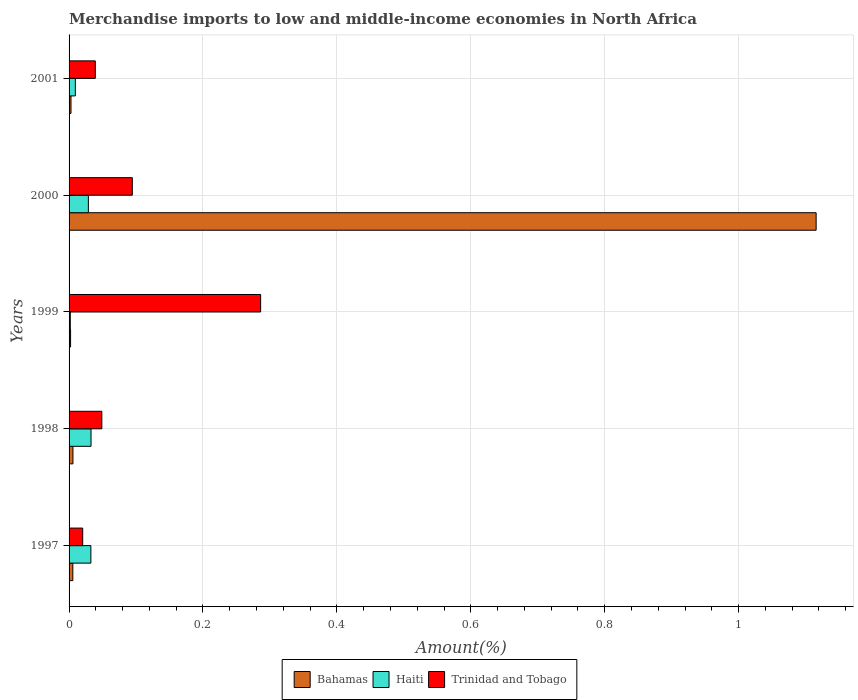How many different coloured bars are there?
Your answer should be compact. 3. Are the number of bars on each tick of the Y-axis equal?
Offer a very short reply. Yes. How many bars are there on the 2nd tick from the top?
Keep it short and to the point. 3. How many bars are there on the 1st tick from the bottom?
Offer a very short reply. 3. What is the percentage of amount earned from merchandise imports in Haiti in 2000?
Make the answer very short. 0.03. Across all years, what is the maximum percentage of amount earned from merchandise imports in Trinidad and Tobago?
Provide a short and direct response. 0.29. Across all years, what is the minimum percentage of amount earned from merchandise imports in Trinidad and Tobago?
Provide a succinct answer. 0.02. In which year was the percentage of amount earned from merchandise imports in Bahamas maximum?
Give a very brief answer. 2000. What is the total percentage of amount earned from merchandise imports in Trinidad and Tobago in the graph?
Make the answer very short. 0.49. What is the difference between the percentage of amount earned from merchandise imports in Bahamas in 1999 and that in 2001?
Give a very brief answer. -0. What is the difference between the percentage of amount earned from merchandise imports in Haiti in 2000 and the percentage of amount earned from merchandise imports in Trinidad and Tobago in 1997?
Make the answer very short. 0.01. What is the average percentage of amount earned from merchandise imports in Trinidad and Tobago per year?
Make the answer very short. 0.1. In the year 1998, what is the difference between the percentage of amount earned from merchandise imports in Bahamas and percentage of amount earned from merchandise imports in Trinidad and Tobago?
Your answer should be very brief. -0.04. In how many years, is the percentage of amount earned from merchandise imports in Haiti greater than 0.28 %?
Offer a terse response. 0. What is the ratio of the percentage of amount earned from merchandise imports in Bahamas in 1997 to that in 1999?
Offer a very short reply. 2.49. Is the difference between the percentage of amount earned from merchandise imports in Bahamas in 1997 and 2000 greater than the difference between the percentage of amount earned from merchandise imports in Trinidad and Tobago in 1997 and 2000?
Provide a succinct answer. No. What is the difference between the highest and the second highest percentage of amount earned from merchandise imports in Bahamas?
Give a very brief answer. 1.11. What is the difference between the highest and the lowest percentage of amount earned from merchandise imports in Bahamas?
Provide a short and direct response. 1.11. In how many years, is the percentage of amount earned from merchandise imports in Haiti greater than the average percentage of amount earned from merchandise imports in Haiti taken over all years?
Your answer should be very brief. 3. Is the sum of the percentage of amount earned from merchandise imports in Haiti in 1997 and 1998 greater than the maximum percentage of amount earned from merchandise imports in Bahamas across all years?
Give a very brief answer. No. What does the 3rd bar from the top in 1999 represents?
Provide a succinct answer. Bahamas. What does the 3rd bar from the bottom in 2000 represents?
Ensure brevity in your answer.  Trinidad and Tobago. Is it the case that in every year, the sum of the percentage of amount earned from merchandise imports in Bahamas and percentage of amount earned from merchandise imports in Trinidad and Tobago is greater than the percentage of amount earned from merchandise imports in Haiti?
Offer a very short reply. No. How many bars are there?
Make the answer very short. 15. How many years are there in the graph?
Provide a succinct answer. 5. Does the graph contain any zero values?
Provide a short and direct response. No. Where does the legend appear in the graph?
Your answer should be compact. Bottom center. How are the legend labels stacked?
Give a very brief answer. Horizontal. What is the title of the graph?
Offer a terse response. Merchandise imports to low and middle-income economies in North Africa. What is the label or title of the X-axis?
Ensure brevity in your answer.  Amount(%). What is the label or title of the Y-axis?
Provide a short and direct response. Years. What is the Amount(%) of Bahamas in 1997?
Ensure brevity in your answer.  0.01. What is the Amount(%) of Haiti in 1997?
Keep it short and to the point. 0.03. What is the Amount(%) in Trinidad and Tobago in 1997?
Give a very brief answer. 0.02. What is the Amount(%) of Bahamas in 1998?
Offer a very short reply. 0.01. What is the Amount(%) in Haiti in 1998?
Ensure brevity in your answer.  0.03. What is the Amount(%) in Trinidad and Tobago in 1998?
Ensure brevity in your answer.  0.05. What is the Amount(%) in Bahamas in 1999?
Your answer should be compact. 0. What is the Amount(%) of Haiti in 1999?
Keep it short and to the point. 0. What is the Amount(%) in Trinidad and Tobago in 1999?
Your answer should be very brief. 0.29. What is the Amount(%) in Bahamas in 2000?
Provide a succinct answer. 1.12. What is the Amount(%) of Haiti in 2000?
Ensure brevity in your answer.  0.03. What is the Amount(%) of Trinidad and Tobago in 2000?
Keep it short and to the point. 0.09. What is the Amount(%) of Bahamas in 2001?
Give a very brief answer. 0. What is the Amount(%) in Haiti in 2001?
Provide a succinct answer. 0.01. What is the Amount(%) of Trinidad and Tobago in 2001?
Give a very brief answer. 0.04. Across all years, what is the maximum Amount(%) of Bahamas?
Your response must be concise. 1.12. Across all years, what is the maximum Amount(%) of Haiti?
Your answer should be very brief. 0.03. Across all years, what is the maximum Amount(%) in Trinidad and Tobago?
Offer a terse response. 0.29. Across all years, what is the minimum Amount(%) of Bahamas?
Your answer should be compact. 0. Across all years, what is the minimum Amount(%) in Haiti?
Your response must be concise. 0. Across all years, what is the minimum Amount(%) of Trinidad and Tobago?
Offer a very short reply. 0.02. What is the total Amount(%) of Bahamas in the graph?
Ensure brevity in your answer.  1.13. What is the total Amount(%) in Haiti in the graph?
Provide a succinct answer. 0.11. What is the total Amount(%) in Trinidad and Tobago in the graph?
Your response must be concise. 0.49. What is the difference between the Amount(%) in Bahamas in 1997 and that in 1998?
Keep it short and to the point. -0. What is the difference between the Amount(%) of Haiti in 1997 and that in 1998?
Offer a very short reply. -0. What is the difference between the Amount(%) of Trinidad and Tobago in 1997 and that in 1998?
Provide a short and direct response. -0.03. What is the difference between the Amount(%) of Bahamas in 1997 and that in 1999?
Offer a terse response. 0. What is the difference between the Amount(%) in Haiti in 1997 and that in 1999?
Keep it short and to the point. 0.03. What is the difference between the Amount(%) of Trinidad and Tobago in 1997 and that in 1999?
Provide a short and direct response. -0.27. What is the difference between the Amount(%) in Bahamas in 1997 and that in 2000?
Offer a terse response. -1.11. What is the difference between the Amount(%) in Haiti in 1997 and that in 2000?
Ensure brevity in your answer.  0. What is the difference between the Amount(%) in Trinidad and Tobago in 1997 and that in 2000?
Keep it short and to the point. -0.07. What is the difference between the Amount(%) in Bahamas in 1997 and that in 2001?
Make the answer very short. 0. What is the difference between the Amount(%) of Haiti in 1997 and that in 2001?
Your response must be concise. 0.02. What is the difference between the Amount(%) in Trinidad and Tobago in 1997 and that in 2001?
Provide a succinct answer. -0.02. What is the difference between the Amount(%) in Bahamas in 1998 and that in 1999?
Make the answer very short. 0. What is the difference between the Amount(%) in Haiti in 1998 and that in 1999?
Ensure brevity in your answer.  0.03. What is the difference between the Amount(%) in Trinidad and Tobago in 1998 and that in 1999?
Make the answer very short. -0.24. What is the difference between the Amount(%) in Bahamas in 1998 and that in 2000?
Ensure brevity in your answer.  -1.11. What is the difference between the Amount(%) of Haiti in 1998 and that in 2000?
Make the answer very short. 0. What is the difference between the Amount(%) in Trinidad and Tobago in 1998 and that in 2000?
Provide a succinct answer. -0.05. What is the difference between the Amount(%) in Bahamas in 1998 and that in 2001?
Keep it short and to the point. 0. What is the difference between the Amount(%) of Haiti in 1998 and that in 2001?
Your response must be concise. 0.02. What is the difference between the Amount(%) of Trinidad and Tobago in 1998 and that in 2001?
Offer a terse response. 0.01. What is the difference between the Amount(%) of Bahamas in 1999 and that in 2000?
Offer a very short reply. -1.11. What is the difference between the Amount(%) in Haiti in 1999 and that in 2000?
Ensure brevity in your answer.  -0.03. What is the difference between the Amount(%) of Trinidad and Tobago in 1999 and that in 2000?
Offer a very short reply. 0.19. What is the difference between the Amount(%) in Bahamas in 1999 and that in 2001?
Offer a very short reply. -0. What is the difference between the Amount(%) in Haiti in 1999 and that in 2001?
Provide a short and direct response. -0.01. What is the difference between the Amount(%) in Trinidad and Tobago in 1999 and that in 2001?
Keep it short and to the point. 0.25. What is the difference between the Amount(%) of Bahamas in 2000 and that in 2001?
Make the answer very short. 1.11. What is the difference between the Amount(%) in Haiti in 2000 and that in 2001?
Offer a terse response. 0.02. What is the difference between the Amount(%) in Trinidad and Tobago in 2000 and that in 2001?
Provide a succinct answer. 0.06. What is the difference between the Amount(%) in Bahamas in 1997 and the Amount(%) in Haiti in 1998?
Offer a terse response. -0.03. What is the difference between the Amount(%) of Bahamas in 1997 and the Amount(%) of Trinidad and Tobago in 1998?
Your answer should be compact. -0.04. What is the difference between the Amount(%) of Haiti in 1997 and the Amount(%) of Trinidad and Tobago in 1998?
Your answer should be very brief. -0.02. What is the difference between the Amount(%) of Bahamas in 1997 and the Amount(%) of Haiti in 1999?
Provide a short and direct response. 0. What is the difference between the Amount(%) of Bahamas in 1997 and the Amount(%) of Trinidad and Tobago in 1999?
Keep it short and to the point. -0.28. What is the difference between the Amount(%) of Haiti in 1997 and the Amount(%) of Trinidad and Tobago in 1999?
Make the answer very short. -0.25. What is the difference between the Amount(%) of Bahamas in 1997 and the Amount(%) of Haiti in 2000?
Make the answer very short. -0.02. What is the difference between the Amount(%) of Bahamas in 1997 and the Amount(%) of Trinidad and Tobago in 2000?
Provide a succinct answer. -0.09. What is the difference between the Amount(%) of Haiti in 1997 and the Amount(%) of Trinidad and Tobago in 2000?
Your response must be concise. -0.06. What is the difference between the Amount(%) of Bahamas in 1997 and the Amount(%) of Haiti in 2001?
Offer a terse response. -0. What is the difference between the Amount(%) of Bahamas in 1997 and the Amount(%) of Trinidad and Tobago in 2001?
Keep it short and to the point. -0.03. What is the difference between the Amount(%) of Haiti in 1997 and the Amount(%) of Trinidad and Tobago in 2001?
Offer a very short reply. -0.01. What is the difference between the Amount(%) of Bahamas in 1998 and the Amount(%) of Haiti in 1999?
Your answer should be compact. 0. What is the difference between the Amount(%) of Bahamas in 1998 and the Amount(%) of Trinidad and Tobago in 1999?
Your response must be concise. -0.28. What is the difference between the Amount(%) in Haiti in 1998 and the Amount(%) in Trinidad and Tobago in 1999?
Keep it short and to the point. -0.25. What is the difference between the Amount(%) in Bahamas in 1998 and the Amount(%) in Haiti in 2000?
Provide a succinct answer. -0.02. What is the difference between the Amount(%) in Bahamas in 1998 and the Amount(%) in Trinidad and Tobago in 2000?
Keep it short and to the point. -0.09. What is the difference between the Amount(%) of Haiti in 1998 and the Amount(%) of Trinidad and Tobago in 2000?
Your response must be concise. -0.06. What is the difference between the Amount(%) in Bahamas in 1998 and the Amount(%) in Haiti in 2001?
Offer a very short reply. -0. What is the difference between the Amount(%) of Bahamas in 1998 and the Amount(%) of Trinidad and Tobago in 2001?
Your answer should be compact. -0.03. What is the difference between the Amount(%) in Haiti in 1998 and the Amount(%) in Trinidad and Tobago in 2001?
Make the answer very short. -0.01. What is the difference between the Amount(%) in Bahamas in 1999 and the Amount(%) in Haiti in 2000?
Offer a very short reply. -0.03. What is the difference between the Amount(%) of Bahamas in 1999 and the Amount(%) of Trinidad and Tobago in 2000?
Your answer should be very brief. -0.09. What is the difference between the Amount(%) in Haiti in 1999 and the Amount(%) in Trinidad and Tobago in 2000?
Make the answer very short. -0.09. What is the difference between the Amount(%) of Bahamas in 1999 and the Amount(%) of Haiti in 2001?
Offer a very short reply. -0.01. What is the difference between the Amount(%) in Bahamas in 1999 and the Amount(%) in Trinidad and Tobago in 2001?
Your answer should be compact. -0.04. What is the difference between the Amount(%) in Haiti in 1999 and the Amount(%) in Trinidad and Tobago in 2001?
Provide a short and direct response. -0.04. What is the difference between the Amount(%) in Bahamas in 2000 and the Amount(%) in Haiti in 2001?
Your response must be concise. 1.11. What is the difference between the Amount(%) in Bahamas in 2000 and the Amount(%) in Trinidad and Tobago in 2001?
Provide a short and direct response. 1.08. What is the difference between the Amount(%) in Haiti in 2000 and the Amount(%) in Trinidad and Tobago in 2001?
Your answer should be very brief. -0.01. What is the average Amount(%) in Bahamas per year?
Ensure brevity in your answer.  0.23. What is the average Amount(%) in Haiti per year?
Give a very brief answer. 0.02. What is the average Amount(%) of Trinidad and Tobago per year?
Offer a terse response. 0.1. In the year 1997, what is the difference between the Amount(%) in Bahamas and Amount(%) in Haiti?
Give a very brief answer. -0.03. In the year 1997, what is the difference between the Amount(%) of Bahamas and Amount(%) of Trinidad and Tobago?
Your response must be concise. -0.01. In the year 1997, what is the difference between the Amount(%) of Haiti and Amount(%) of Trinidad and Tobago?
Offer a terse response. 0.01. In the year 1998, what is the difference between the Amount(%) of Bahamas and Amount(%) of Haiti?
Ensure brevity in your answer.  -0.03. In the year 1998, what is the difference between the Amount(%) in Bahamas and Amount(%) in Trinidad and Tobago?
Your response must be concise. -0.04. In the year 1998, what is the difference between the Amount(%) of Haiti and Amount(%) of Trinidad and Tobago?
Offer a terse response. -0.02. In the year 1999, what is the difference between the Amount(%) in Bahamas and Amount(%) in Haiti?
Offer a terse response. 0. In the year 1999, what is the difference between the Amount(%) in Bahamas and Amount(%) in Trinidad and Tobago?
Provide a succinct answer. -0.28. In the year 1999, what is the difference between the Amount(%) in Haiti and Amount(%) in Trinidad and Tobago?
Offer a very short reply. -0.28. In the year 2000, what is the difference between the Amount(%) of Bahamas and Amount(%) of Haiti?
Offer a terse response. 1.09. In the year 2000, what is the difference between the Amount(%) in Bahamas and Amount(%) in Trinidad and Tobago?
Make the answer very short. 1.02. In the year 2000, what is the difference between the Amount(%) of Haiti and Amount(%) of Trinidad and Tobago?
Provide a succinct answer. -0.07. In the year 2001, what is the difference between the Amount(%) of Bahamas and Amount(%) of Haiti?
Offer a very short reply. -0.01. In the year 2001, what is the difference between the Amount(%) in Bahamas and Amount(%) in Trinidad and Tobago?
Your answer should be very brief. -0.04. In the year 2001, what is the difference between the Amount(%) in Haiti and Amount(%) in Trinidad and Tobago?
Keep it short and to the point. -0.03. What is the ratio of the Amount(%) in Bahamas in 1997 to that in 1998?
Offer a very short reply. 0.97. What is the ratio of the Amount(%) of Haiti in 1997 to that in 1998?
Your response must be concise. 0.99. What is the ratio of the Amount(%) in Trinidad and Tobago in 1997 to that in 1998?
Offer a terse response. 0.42. What is the ratio of the Amount(%) of Bahamas in 1997 to that in 1999?
Give a very brief answer. 2.49. What is the ratio of the Amount(%) in Haiti in 1997 to that in 1999?
Give a very brief answer. 17.62. What is the ratio of the Amount(%) of Trinidad and Tobago in 1997 to that in 1999?
Provide a short and direct response. 0.07. What is the ratio of the Amount(%) in Bahamas in 1997 to that in 2000?
Your answer should be compact. 0.01. What is the ratio of the Amount(%) in Haiti in 1997 to that in 2000?
Offer a very short reply. 1.13. What is the ratio of the Amount(%) of Trinidad and Tobago in 1997 to that in 2000?
Ensure brevity in your answer.  0.22. What is the ratio of the Amount(%) in Bahamas in 1997 to that in 2001?
Your answer should be compact. 1.94. What is the ratio of the Amount(%) in Haiti in 1997 to that in 2001?
Provide a succinct answer. 3.48. What is the ratio of the Amount(%) of Trinidad and Tobago in 1997 to that in 2001?
Offer a very short reply. 0.52. What is the ratio of the Amount(%) of Bahamas in 1998 to that in 1999?
Give a very brief answer. 2.57. What is the ratio of the Amount(%) of Haiti in 1998 to that in 1999?
Provide a short and direct response. 17.74. What is the ratio of the Amount(%) of Trinidad and Tobago in 1998 to that in 1999?
Your answer should be compact. 0.17. What is the ratio of the Amount(%) of Bahamas in 1998 to that in 2000?
Give a very brief answer. 0.01. What is the ratio of the Amount(%) of Haiti in 1998 to that in 2000?
Your response must be concise. 1.14. What is the ratio of the Amount(%) in Trinidad and Tobago in 1998 to that in 2000?
Ensure brevity in your answer.  0.52. What is the ratio of the Amount(%) in Bahamas in 1998 to that in 2001?
Offer a terse response. 2. What is the ratio of the Amount(%) in Haiti in 1998 to that in 2001?
Make the answer very short. 3.5. What is the ratio of the Amount(%) in Bahamas in 1999 to that in 2000?
Your answer should be very brief. 0. What is the ratio of the Amount(%) of Haiti in 1999 to that in 2000?
Provide a short and direct response. 0.06. What is the ratio of the Amount(%) in Trinidad and Tobago in 1999 to that in 2000?
Your answer should be compact. 3.03. What is the ratio of the Amount(%) of Bahamas in 1999 to that in 2001?
Provide a succinct answer. 0.78. What is the ratio of the Amount(%) of Haiti in 1999 to that in 2001?
Give a very brief answer. 0.2. What is the ratio of the Amount(%) of Trinidad and Tobago in 1999 to that in 2001?
Provide a short and direct response. 7.31. What is the ratio of the Amount(%) in Bahamas in 2000 to that in 2001?
Keep it short and to the point. 386.59. What is the ratio of the Amount(%) in Haiti in 2000 to that in 2001?
Your answer should be very brief. 3.08. What is the ratio of the Amount(%) in Trinidad and Tobago in 2000 to that in 2001?
Your answer should be compact. 2.41. What is the difference between the highest and the second highest Amount(%) of Bahamas?
Offer a terse response. 1.11. What is the difference between the highest and the second highest Amount(%) in Haiti?
Give a very brief answer. 0. What is the difference between the highest and the second highest Amount(%) of Trinidad and Tobago?
Provide a succinct answer. 0.19. What is the difference between the highest and the lowest Amount(%) in Bahamas?
Ensure brevity in your answer.  1.11. What is the difference between the highest and the lowest Amount(%) of Haiti?
Offer a terse response. 0.03. What is the difference between the highest and the lowest Amount(%) in Trinidad and Tobago?
Your answer should be compact. 0.27. 